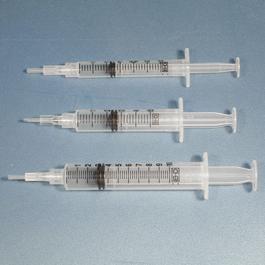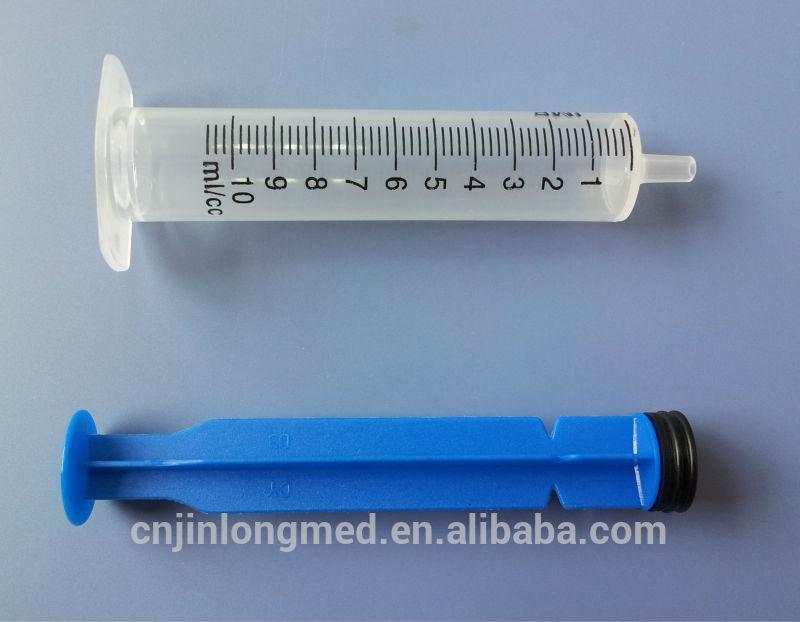The first image is the image on the left, the second image is the image on the right. For the images shown, is this caption "There is exactly one syringe in the right image." true? Answer yes or no. Yes. The first image is the image on the left, the second image is the image on the right. Evaluate the accuracy of this statement regarding the images: "There are no more than two syringes.". Is it true? Answer yes or no. No. 